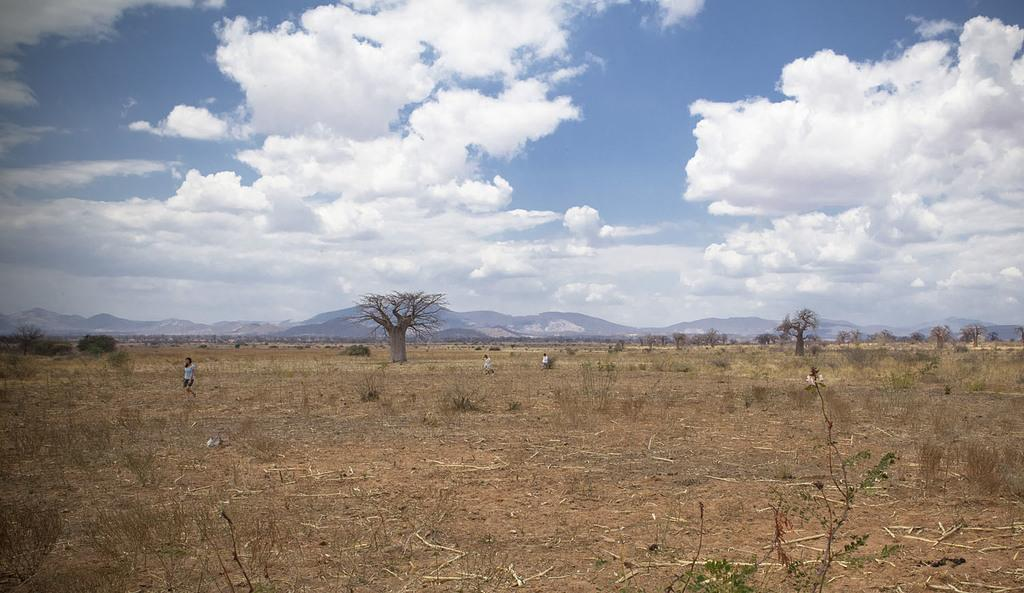Who is the main subject in the image? There is a girl in the image. What is the girl doing in the image? The girl is walking. What type of natural environment is visible in the image? There are trees in the image. What is the condition of the sky in the image? The sky appears to be sunny in the image. What account does the girl have with the bank in the image? There is no mention of a bank or an account in the image. What type of footwear is the girl wearing in the image? The image does not show the girl's footwear. 